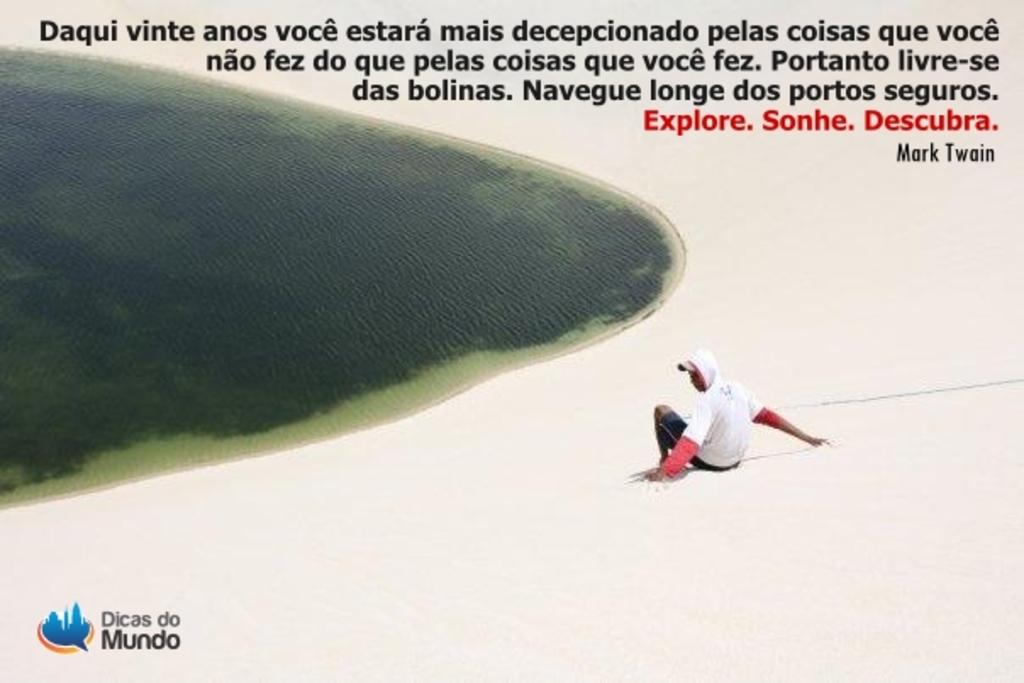<image>
Create a compact narrative representing the image presented. A tourist picture of a man on the beach for Dicas do Mundo. 